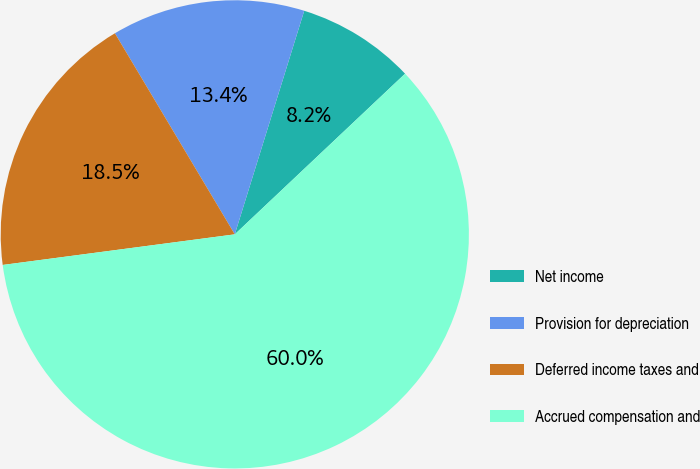Convert chart to OTSL. <chart><loc_0><loc_0><loc_500><loc_500><pie_chart><fcel>Net income<fcel>Provision for depreciation<fcel>Deferred income taxes and<fcel>Accrued compensation and<nl><fcel>8.17%<fcel>13.35%<fcel>18.53%<fcel>59.95%<nl></chart> 